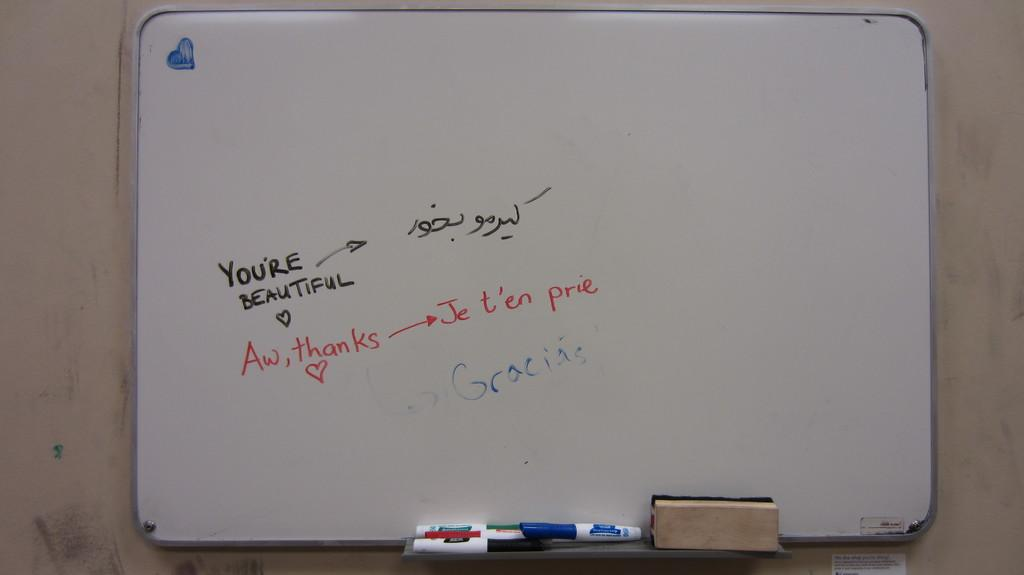Provide a one-sentence caption for the provided image. A white board says "You're beautiful" with "aw, thanks" written on underneath. 